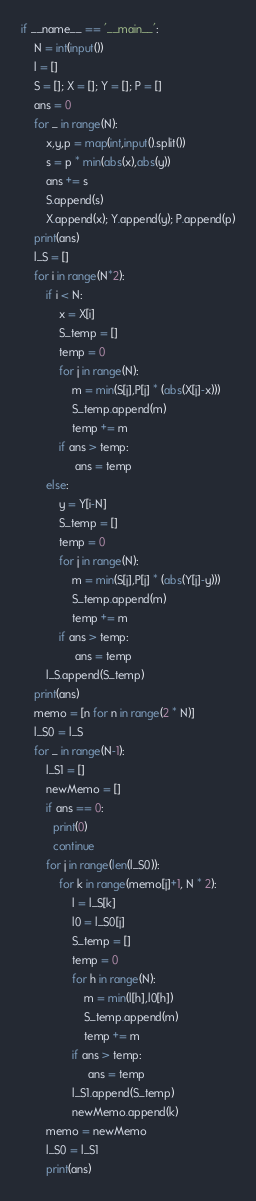<code> <loc_0><loc_0><loc_500><loc_500><_Cython_>if __name__ == '__main__':
    N = int(input())
    l = []
    S = []; X = []; Y = []; P = []
    ans = 0
    for _ in range(N):
        x,y,p = map(int,input().split())
        s = p * min(abs(x),abs(y))
        ans += s
        S.append(s)
        X.append(x); Y.append(y); P.append(p)
    print(ans)
    l_S = []
    for i in range(N*2):
        if i < N:
            x = X[i]
            S_temp = []
            temp = 0
            for j in range(N):
                m = min(S[j],P[j] * (abs(X[j]-x)))
                S_temp.append(m)
                temp += m
            if ans > temp:
                 ans = temp
        else:
            y = Y[i-N]
            S_temp = []
            temp = 0
            for j in range(N):
                m = min(S[j],P[j] * (abs(Y[j]-y)))
                S_temp.append(m)
                temp += m
            if ans > temp:
                 ans = temp
        l_S.append(S_temp)
    print(ans)
    memo = [n for n in range(2 * N)]
    l_S0 = l_S
    for _ in range(N-1):
        l_S1 = []
        newMemo = []
        if ans == 0:
          print(0)
          continue
        for j in range(len(l_S0)):
            for k in range(memo[j]+1, N * 2):
                l = l_S[k]
                l0 = l_S0[j]
                S_temp = []
                temp = 0
                for h in range(N):
                    m = min(l[h],l0[h])
                    S_temp.append(m)
                    temp += m
                if ans > temp:
                     ans = temp
                l_S1.append(S_temp)
                newMemo.append(k)
        memo = newMemo
        l_S0 = l_S1
        print(ans)</code> 